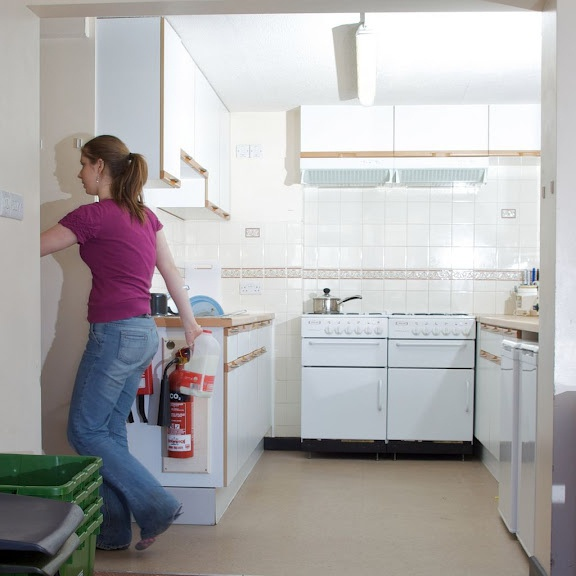Describe the objects in this image and their specific colors. I can see people in darkgray, blue, purple, and black tones, oven in darkgray and lightgray tones, knife in darkgray, lightgray, and gray tones, knife in darkgray and lightgray tones, and knife in darkgray, gray, darkblue, and blue tones in this image. 